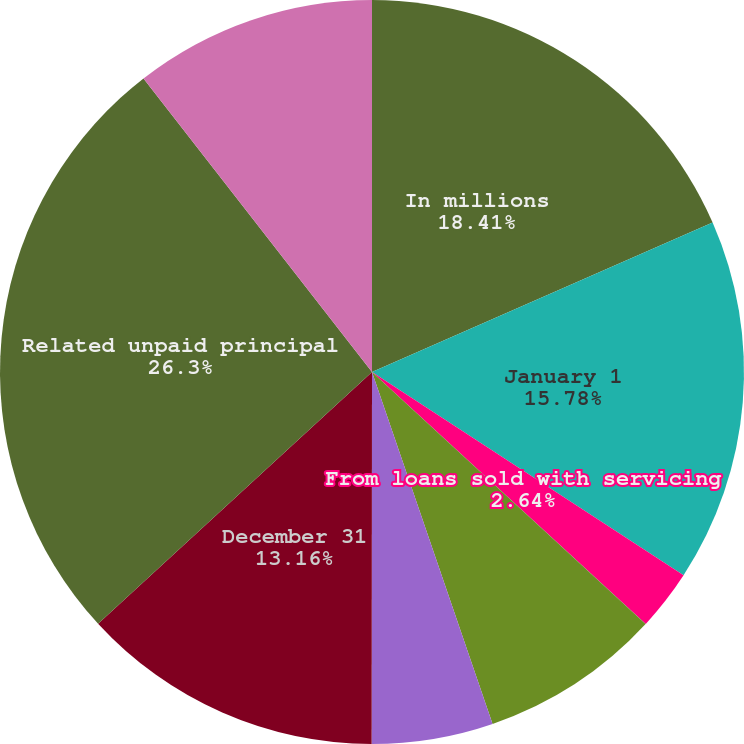Convert chart to OTSL. <chart><loc_0><loc_0><loc_500><loc_500><pie_chart><fcel>In millions<fcel>January 1<fcel>From loans sold with servicing<fcel>Purchases<fcel>Time and payoffs (a)<fcel>Other (b)<fcel>December 31<fcel>Related unpaid principal<fcel>Servicing advances at December<nl><fcel>18.42%<fcel>15.79%<fcel>2.64%<fcel>0.01%<fcel>7.9%<fcel>5.27%<fcel>13.16%<fcel>26.31%<fcel>10.53%<nl></chart> 